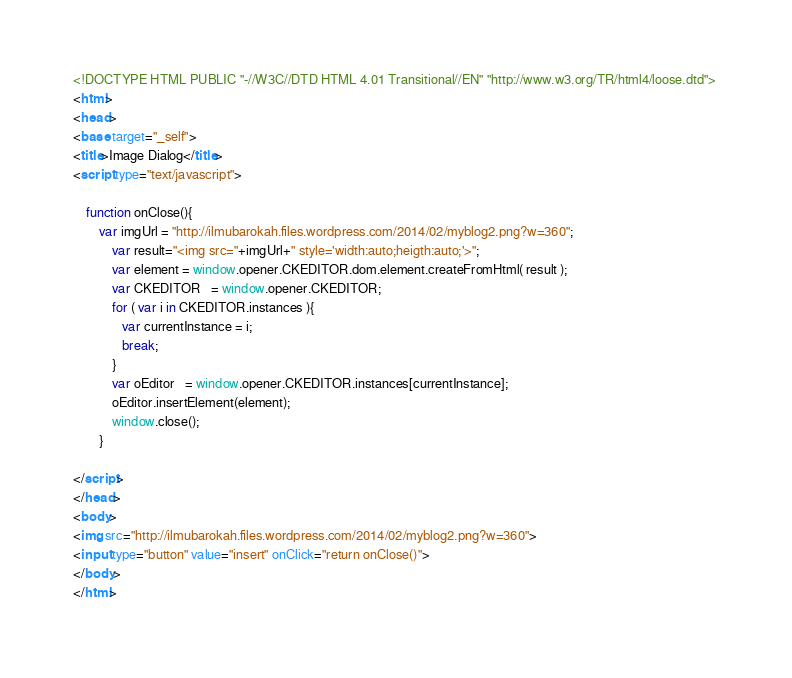<code> <loc_0><loc_0><loc_500><loc_500><_HTML_><!DOCTYPE HTML PUBLIC "-//W3C//DTD HTML 4.01 Transitional//EN" "http://www.w3.org/TR/html4/loose.dtd"> 
<html>
<head>
<base target="_self">
<title>Image Dialog</title>
<script type="text/javascript">
	
	function onClose(){
		var imgUrl = "http://ilmubarokah.files.wordpress.com/2014/02/myblog2.png?w=360";
			var result="<img src="+imgUrl+" style='width:auto;heigth:auto;'>";
			var element = window.opener.CKEDITOR.dom.element.createFromHtml( result );
			var CKEDITOR   = window.opener.CKEDITOR;   
			for ( var i in CKEDITOR.instances ){
			   var currentInstance = i;
			   break;
			}
			var oEditor   = window.opener.CKEDITOR.instances[currentInstance];     
			oEditor.insertElement(element);
			window.close();
		}
	
</script>
</head>
<body>
<img src="http://ilmubarokah.files.wordpress.com/2014/02/myblog2.png?w=360">
<input type="button" value="insert" onClick="return onClose()">
</body>
</html></code> 